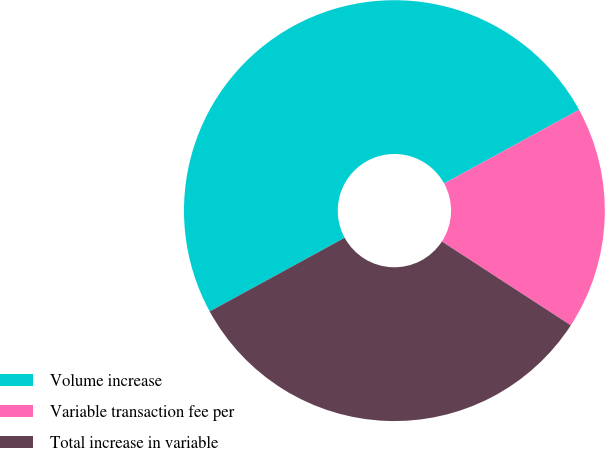<chart> <loc_0><loc_0><loc_500><loc_500><pie_chart><fcel>Volume increase<fcel>Variable transaction fee per<fcel>Total increase in variable<nl><fcel>50.0%<fcel>17.13%<fcel>32.87%<nl></chart> 